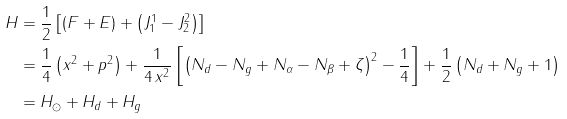Convert formula to latex. <formula><loc_0><loc_0><loc_500><loc_500>H & = \frac { 1 } { 2 } \left [ \left ( F + E \right ) + \left ( J ^ { 1 } _ { 1 } - J ^ { 2 } _ { 2 } \right ) \right ] \\ & = \frac { 1 } { 4 } \left ( x ^ { 2 } + p ^ { 2 } \right ) + \frac { 1 } { 4 \, x ^ { 2 } } \left [ \left ( N _ { d } - N _ { g } + N _ { \alpha } - N _ { \beta } + \zeta \right ) ^ { 2 } - \frac { 1 } { 4 } \right ] + \frac { 1 } { 2 } \left ( N _ { d } + N _ { g } + 1 \right ) \\ & = H _ { \odot } + H _ { d } + H _ { g }</formula> 